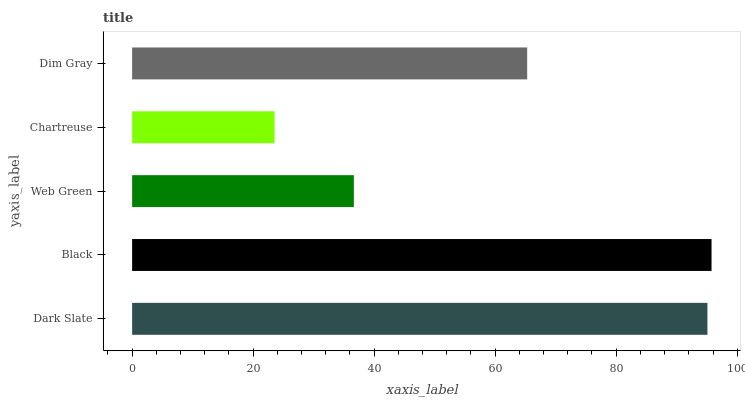Is Chartreuse the minimum?
Answer yes or no. Yes. Is Black the maximum?
Answer yes or no. Yes. Is Web Green the minimum?
Answer yes or no. No. Is Web Green the maximum?
Answer yes or no. No. Is Black greater than Web Green?
Answer yes or no. Yes. Is Web Green less than Black?
Answer yes or no. Yes. Is Web Green greater than Black?
Answer yes or no. No. Is Black less than Web Green?
Answer yes or no. No. Is Dim Gray the high median?
Answer yes or no. Yes. Is Dim Gray the low median?
Answer yes or no. Yes. Is Dark Slate the high median?
Answer yes or no. No. Is Black the low median?
Answer yes or no. No. 